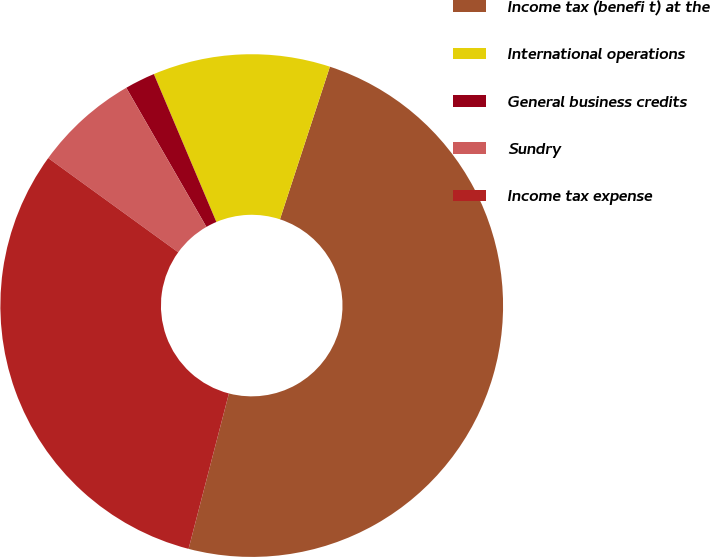<chart> <loc_0><loc_0><loc_500><loc_500><pie_chart><fcel>Income tax (benefi t) at the<fcel>International operations<fcel>General business credits<fcel>Sundry<fcel>Income tax expense<nl><fcel>49.01%<fcel>11.4%<fcel>1.95%<fcel>6.7%<fcel>30.94%<nl></chart> 